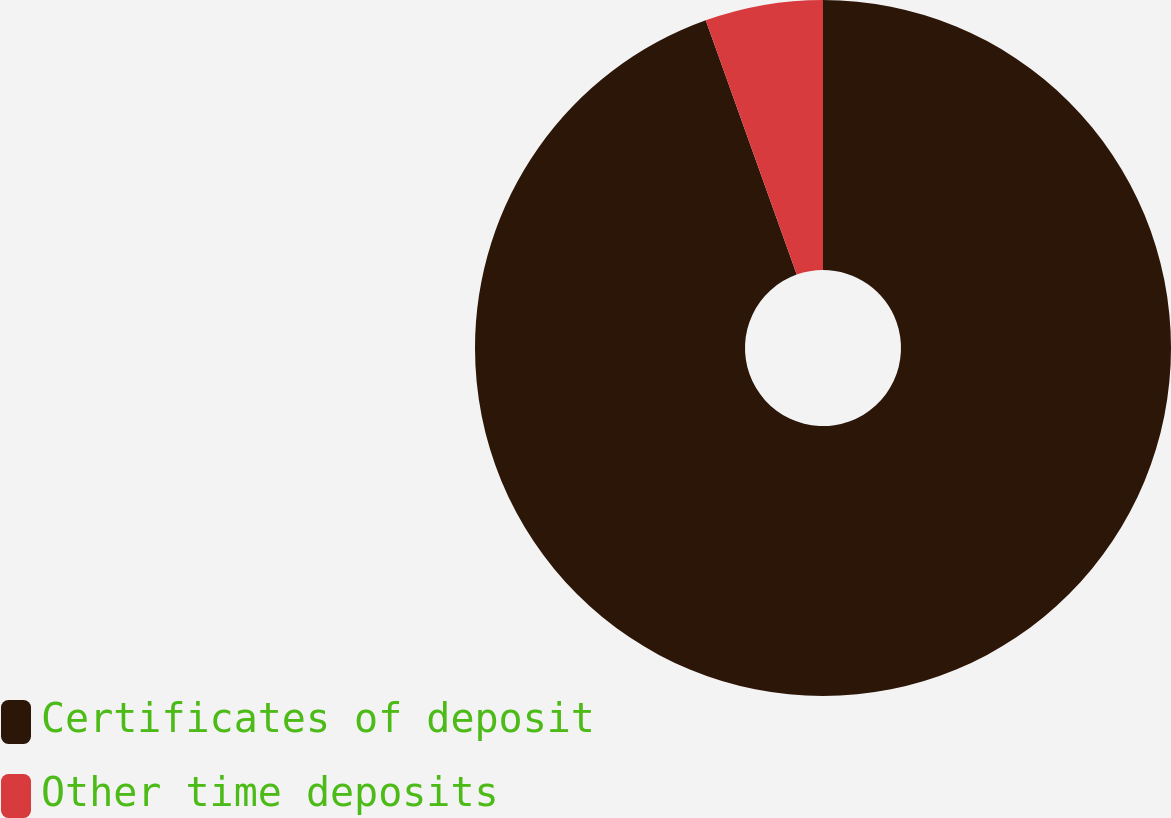<chart> <loc_0><loc_0><loc_500><loc_500><pie_chart><fcel>Certificates of deposit<fcel>Other time deposits<nl><fcel>94.53%<fcel>5.47%<nl></chart> 